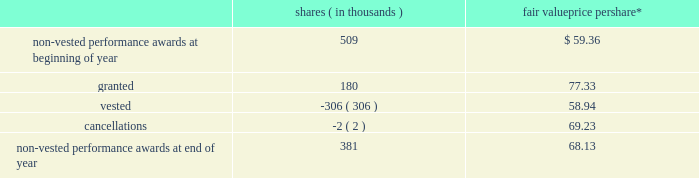The fair value of performance awards is calculated using the market value of a share of snap-on 2019s common stock on the date of grant .
The weighted-average grant date fair value of performance awards granted during 2013 , 2012 and 2011 was $ 77.33 , $ 60.00 and $ 55.97 , respectively .
Vested performance share units approximated 148000 shares as of 2013 year end , 213000 shares as of 2012 year end and 54208 shares as of 2011 year end .
Performance share units of 213459 shares were paid out in 2013 and 53990 shares were paid out in 2012 ; no performance share units were paid out in 2011 .
Earned performance share units are generally paid out following the conclusion of the applicable performance period upon approval by the organization and executive compensation committee of the company 2019s board of directors ( the 201cboard 201d ) .
Based on the company 2019s 2013 performance , 84413 rsus granted in 2013 were earned ; assuming continued employment , these rsus will vest at the end of fiscal 2015 .
Based on the company 2019s 2012 performance , 95047 rsus granted in 2012 were earned ; assuming continued employment , these rsus will vest at the end of fiscal 2014 .
Based on the company 2019s 2011 performance , 159970 rsus granted in 2011 were earned ; these rsus vested as of fiscal 2013 year end and were paid out shortly thereafter .
As a result of employee retirements , a total of 1614 of the rsus earned in 2012 and 2011 vested pursuant to the terms of the related award agreements and the underlying shares were paid out in the third quarter of 2013 .
The changes to the company 2019s non-vested performance awards in 2013 are as follows : shares ( in thousands ) fair value price per share* .
* weighted-average as of 2013 year end there was approximately $ 12.9 million of unrecognized compensation cost related to non-vested performance awards that is expected to be recognized as a charge to earnings over a weighted-average period of 1.6 years .
Stock appreciation rights ( 201csars 201d ) the company also issues cash-settled and stock-settled sars to certain key non-u.s .
Employees .
Sars have a contractual term of ten years and vest ratably on the first , second and third anniversaries of the date of grant .
Sars are granted with an exercise price equal to the market value of a share of snap-on 2019s common stock on the date of grant .
Cash-settled sars provide for the cash payment of the excess of the fair market value of snap-on 2019s common stock price on the date of exercise over the grant price .
Cash-settled sars have no effect on dilutive shares or shares outstanding as any appreciation of snap-on 2019s common stock value over the grant price is paid in cash and not in common stock .
In 2013 , the company began issuing stock-settled sars that are accounted for as equity instruments and provide for the issuance of snap-on common stock equal to the amount by which the company 2019s stock has appreciated over the exercise price .
Stock-settled sars have an effect on dilutive shares and shares outstanding as any appreciation of snap-on 2019s common stock value over the exercise price will be settled in shares of common stock .
2013 annual report 101 .
What is the percentage change in the number of non-vested performance awards from 2012 to 2013? 
Computations: ((381 - 509) / 509)
Answer: -0.25147. 